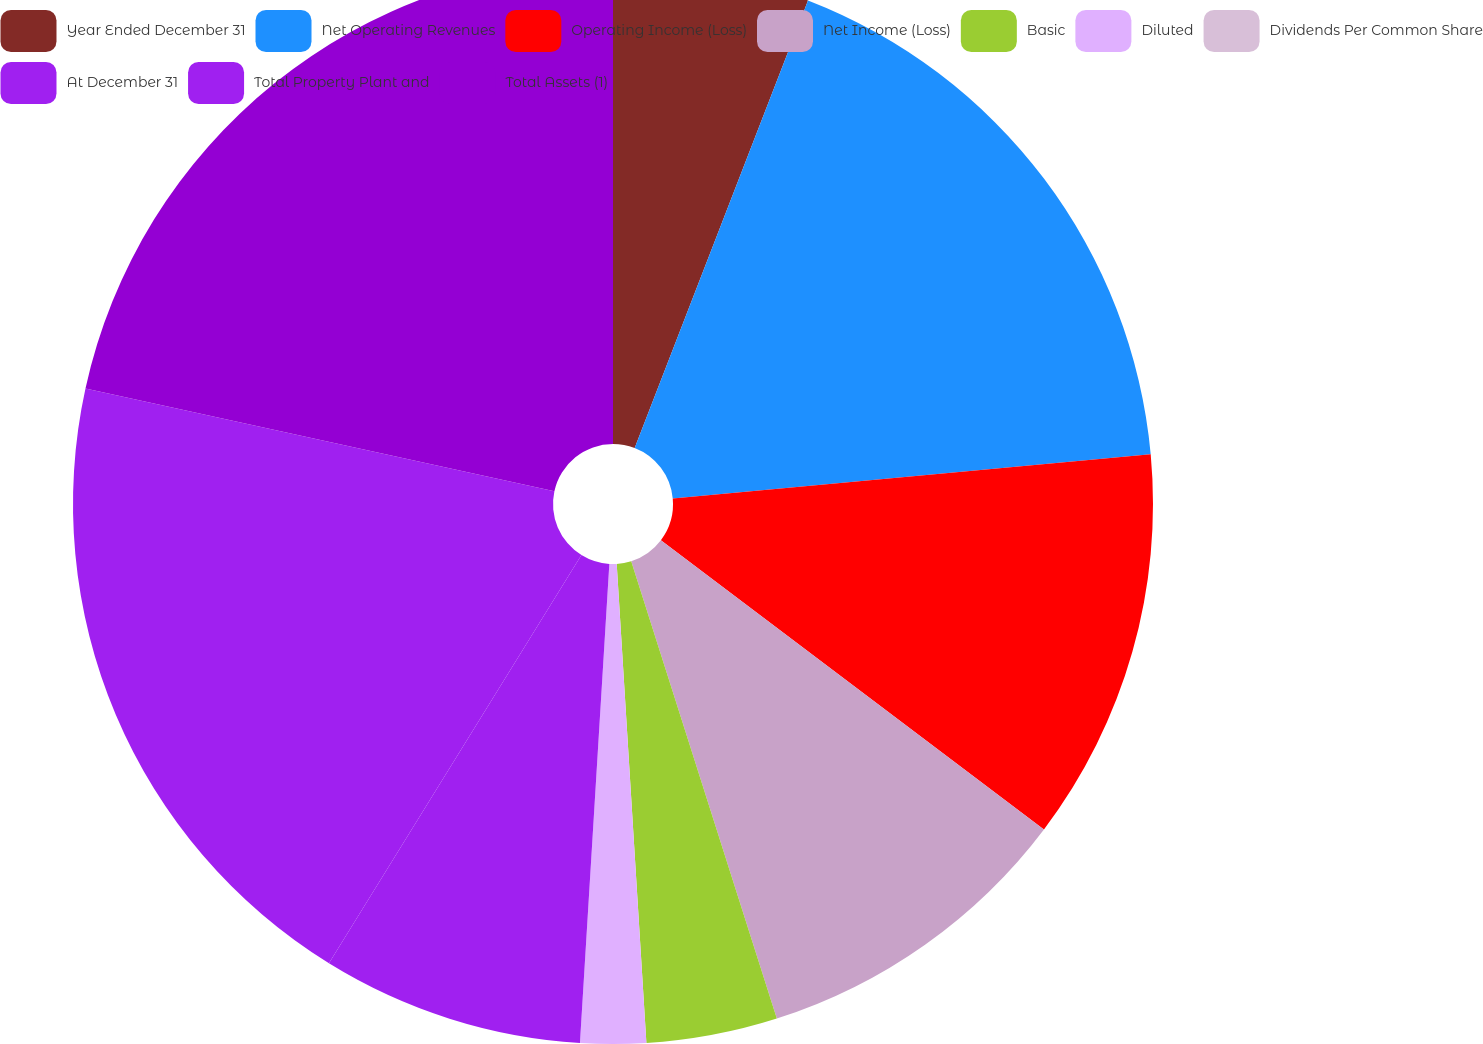<chart> <loc_0><loc_0><loc_500><loc_500><pie_chart><fcel>Year Ended December 31<fcel>Net Operating Revenues<fcel>Operating Income (Loss)<fcel>Net Income (Loss)<fcel>Basic<fcel>Diluted<fcel>Dividends Per Common Share<fcel>At December 31<fcel>Total Property Plant and<fcel>Total Assets (1)<nl><fcel>5.88%<fcel>17.65%<fcel>11.76%<fcel>9.8%<fcel>3.92%<fcel>1.96%<fcel>0.0%<fcel>7.84%<fcel>19.61%<fcel>21.57%<nl></chart> 